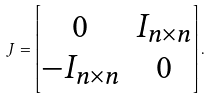<formula> <loc_0><loc_0><loc_500><loc_500>J = \begin{bmatrix} 0 & I _ { n \times n } \\ - I _ { n \times n } & 0 \end{bmatrix} .</formula> 